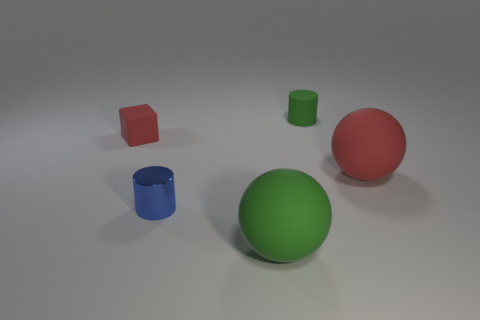Subtract 2 spheres. How many spheres are left? 0 Subtract all blue cylinders. How many cylinders are left? 1 Add 4 tiny metal objects. How many objects exist? 9 Subtract all red blocks. Subtract all tiny red rubber blocks. How many objects are left? 3 Add 4 large red rubber balls. How many large red rubber balls are left? 5 Add 4 yellow things. How many yellow things exist? 4 Subtract 0 cyan balls. How many objects are left? 5 Subtract all balls. How many objects are left? 3 Subtract all yellow cubes. Subtract all red cylinders. How many cubes are left? 1 Subtract all gray cubes. How many red balls are left? 1 